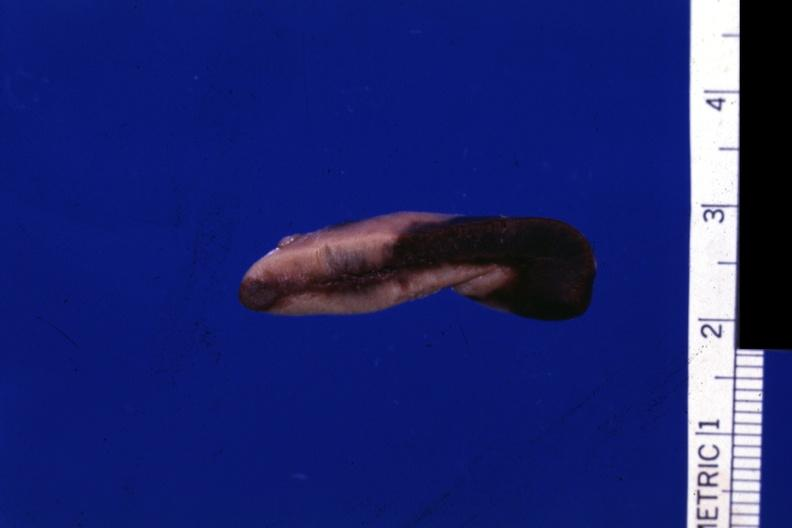s endocrine present?
Answer the question using a single word or phrase. Yes 